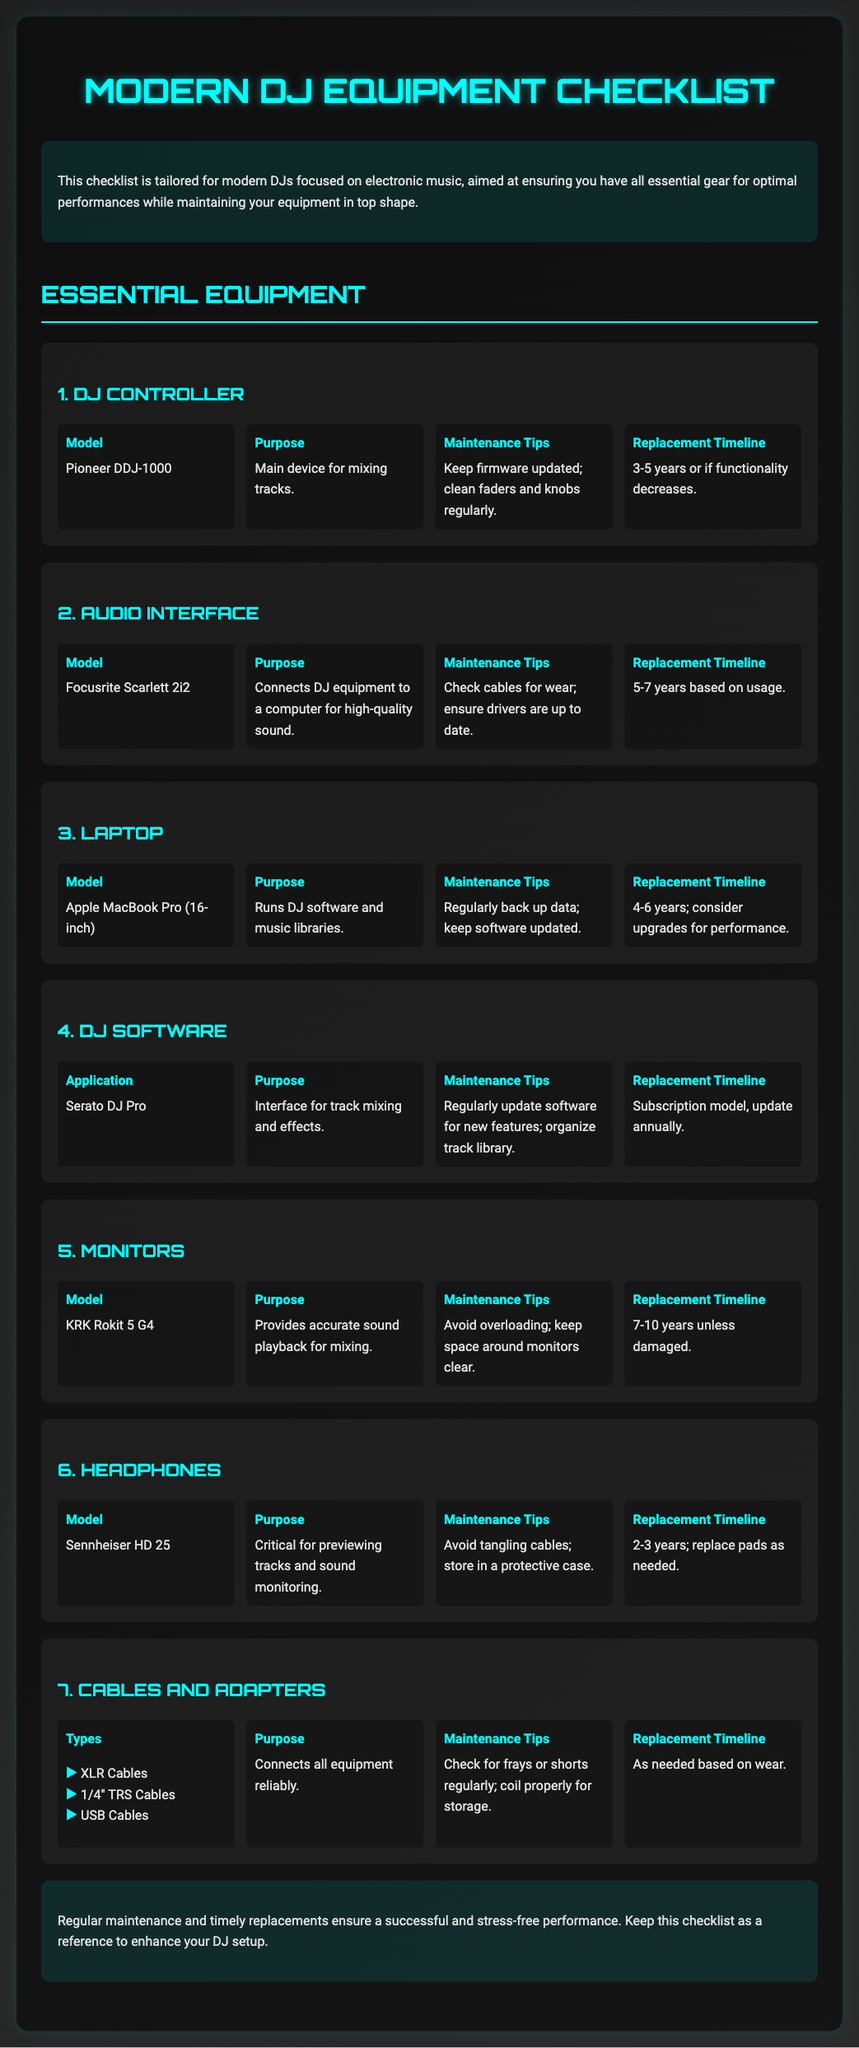What is the model of the DJ controller? The document lists the model of the DJ controller as Pioneer DDJ-1000.
Answer: Pioneer DDJ-1000 What is the purpose of the audio interface? According to the document, the purpose of the audio interface is to connect DJ equipment to a computer for high-quality sound.
Answer: Connects DJ equipment to a computer for high-quality sound What is the maintenance tip for headphones? The document suggests avoiding tangling cables and storing them in a protective case.
Answer: Avoid tangling cables; store in a protective case How often should the DJ software be updated? It is indicated in the document that the DJ software should be updated regularly for new features.
Answer: Regularly What is the replacement timeline for monitors? The document states that monitors should be replaced every 7-10 years unless damaged.
Answer: 7-10 years What device runs the DJ software? The document specifies that the laptop runs DJ software and music libraries.
Answer: Laptop What types of cables are mentioned? The document lists XLR Cables, 1/4" TRS Cables, and USB Cables as types of cables.
Answer: XLR Cables, 1/4" TRS Cables, USB Cables What is the replacement timeline for DJ controllers? The document suggests replacing DJ controllers every 3-5 years or if functionality decreases.
Answer: 3-5 years What is the primary purpose of the KRK Rokit 5 G4? The document states that the primary purpose is to provide accurate sound playback for mixing.
Answer: Provides accurate sound playback for mixing 